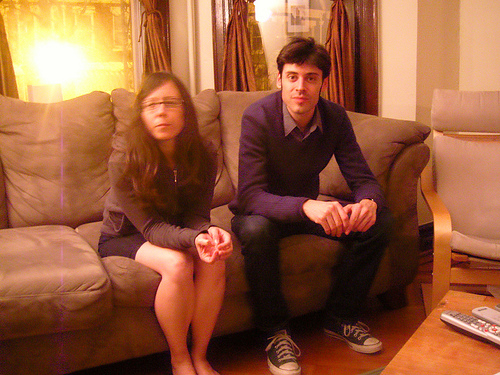<image>
Is there a man next to the woman? Yes. The man is positioned adjacent to the woman, located nearby in the same general area. 